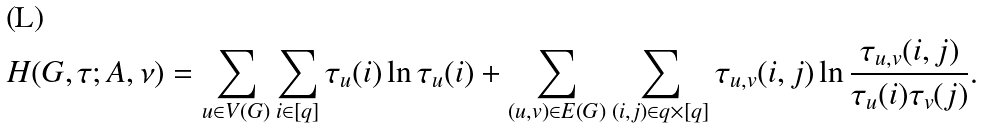Convert formula to latex. <formula><loc_0><loc_0><loc_500><loc_500>H ( G , \tau ; A , \nu ) = \sum _ { u \in V ( G ) } \sum _ { i \in [ q ] } \tau _ { u } ( i ) \ln \tau _ { u } ( i ) + \sum _ { ( u , v ) \in E ( G ) } \sum _ { ( i , j ) \in { q } \times [ q ] } \tau _ { u , v } ( i , j ) \ln \frac { \tau _ { u , v } ( i , j ) } { \tau _ { u } ( i ) \tau _ { v } ( j ) } .</formula> 